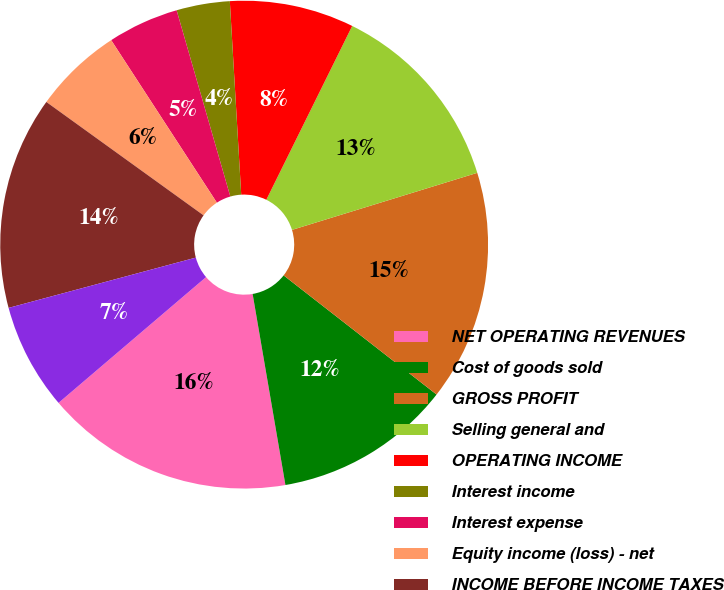Convert chart to OTSL. <chart><loc_0><loc_0><loc_500><loc_500><pie_chart><fcel>NET OPERATING REVENUES<fcel>Cost of goods sold<fcel>GROSS PROFIT<fcel>Selling general and<fcel>OPERATING INCOME<fcel>Interest income<fcel>Interest expense<fcel>Equity income (loss) - net<fcel>INCOME BEFORE INCOME TAXES<fcel>Income taxes<nl><fcel>16.47%<fcel>11.76%<fcel>15.29%<fcel>12.94%<fcel>8.24%<fcel>3.53%<fcel>4.71%<fcel>5.88%<fcel>14.12%<fcel>7.06%<nl></chart> 